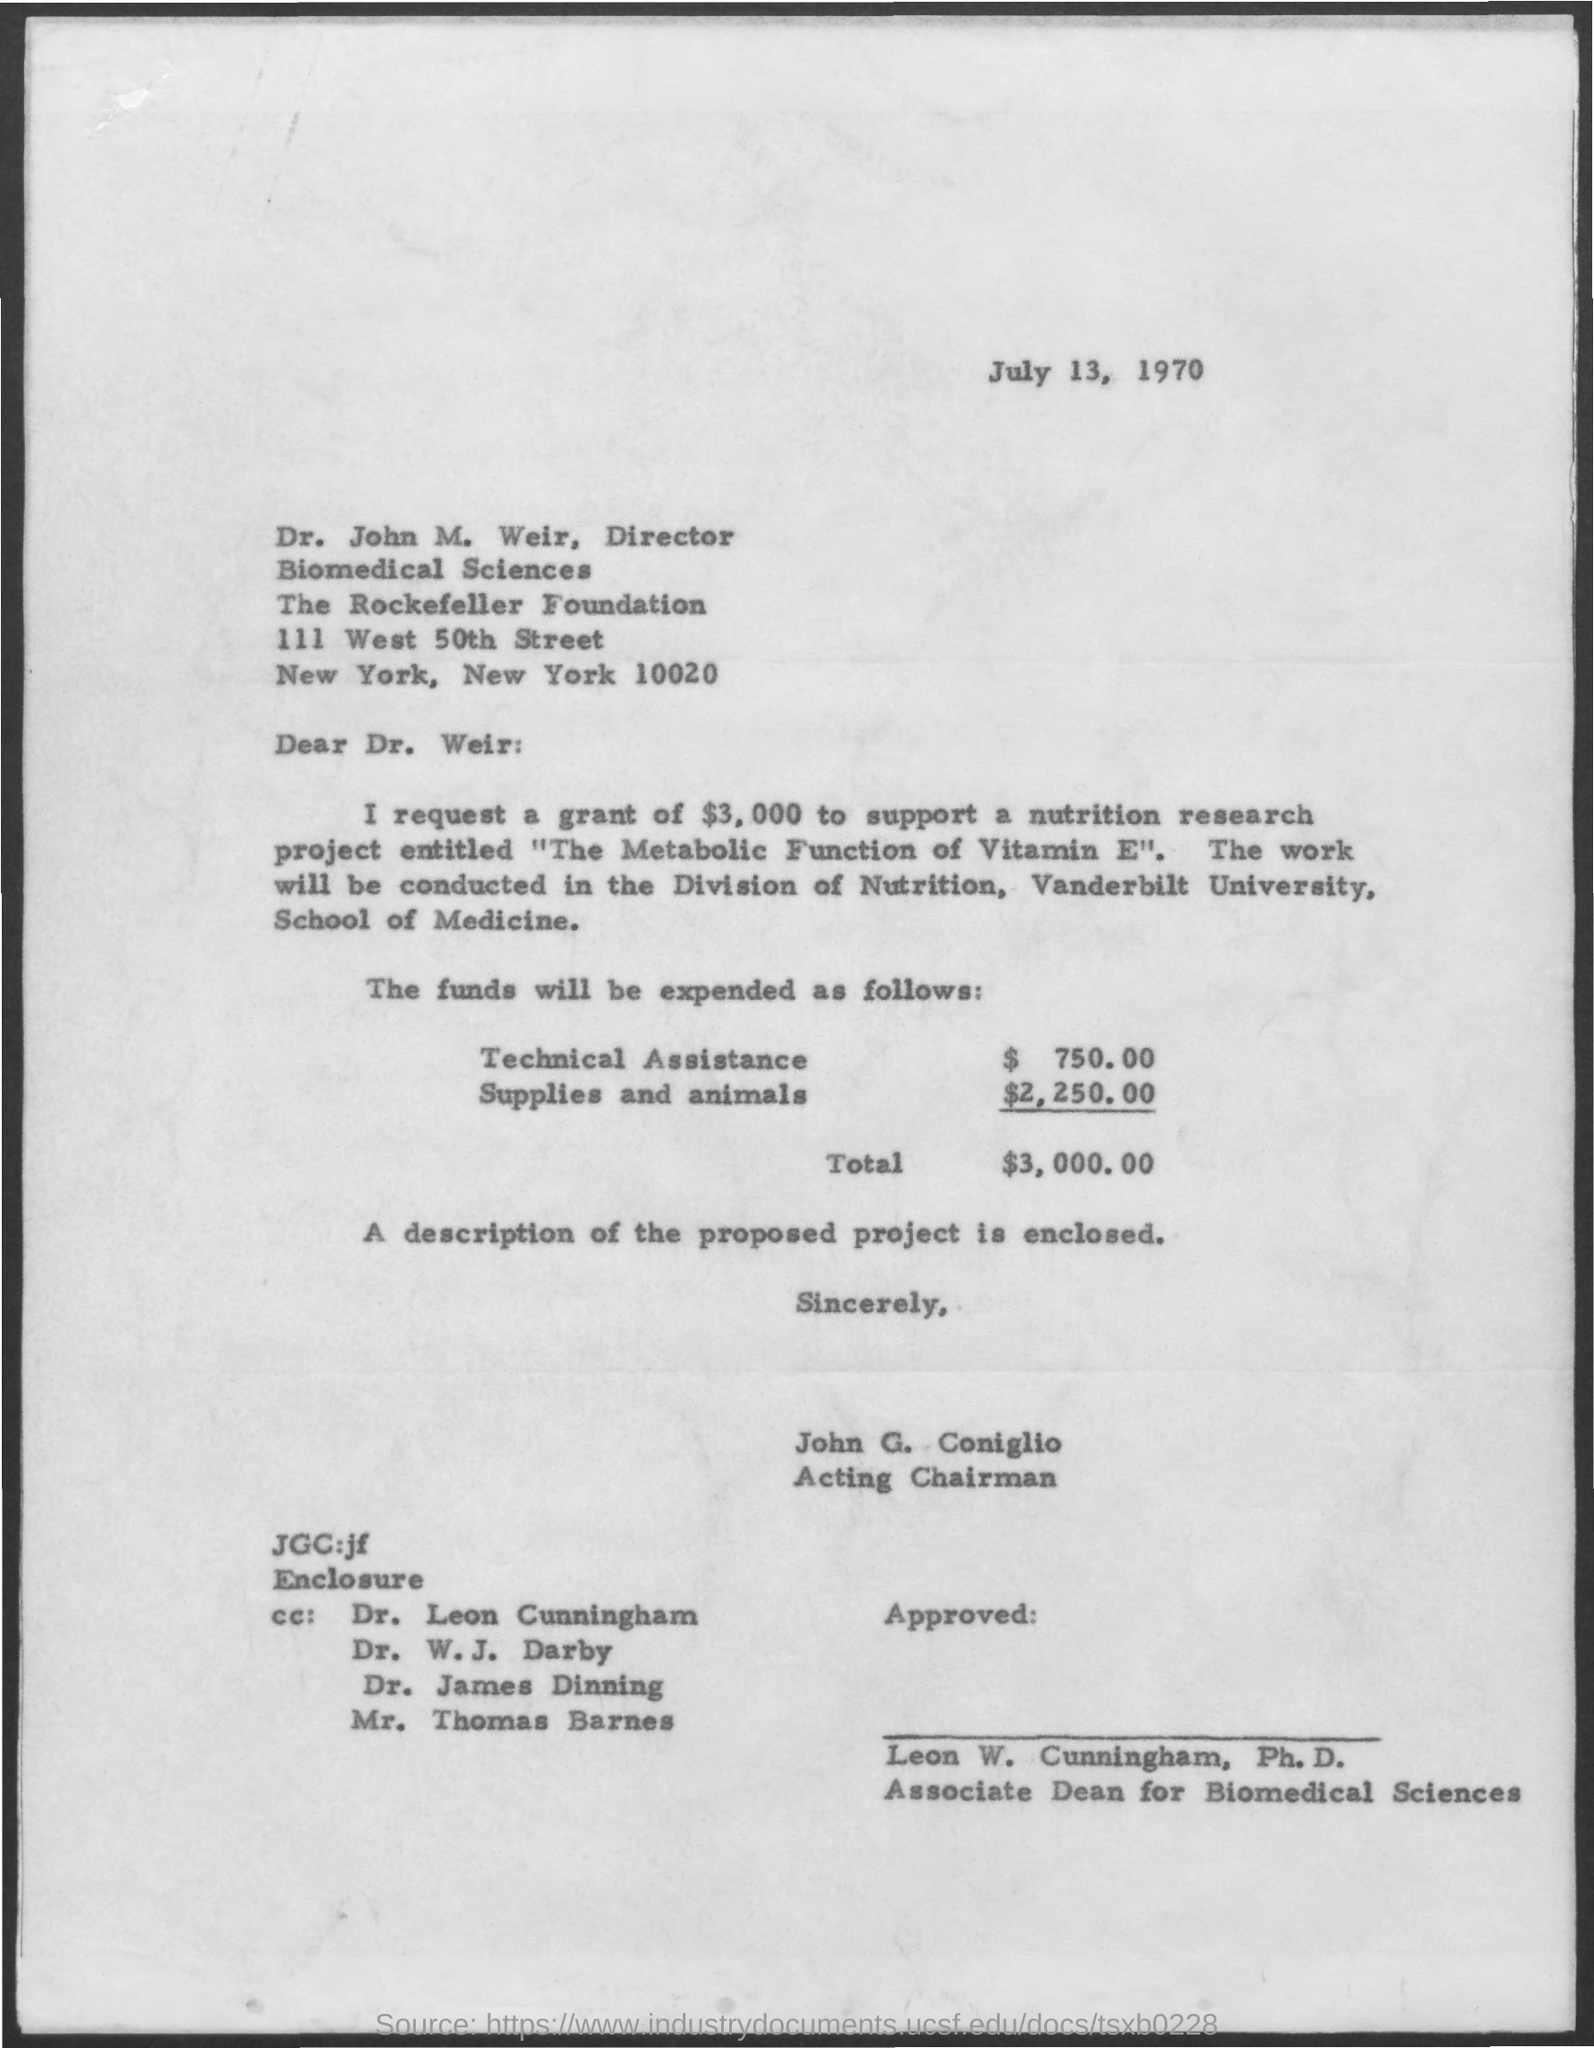What is the date mentioned in the given page ?
Make the answer very short. July 13, 1970. What is the designation of dr. john m. weir ?
Provide a short and direct response. Director. What is the amount mentioned for technical assistance ?
Offer a terse response. $  750.00. What is the amount mentioned for supplies and animals ?
Your answer should be very brief. $ 2,250.00. What is the total amount mentioned in the given form ?
Offer a terse response. $3,000.00. 